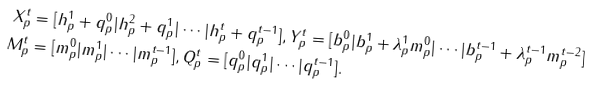<formula> <loc_0><loc_0><loc_500><loc_500>X _ { p } ^ { t } & = [ h _ { p } ^ { 1 } + q _ { p } ^ { 0 } | h _ { p } ^ { 2 } + q _ { p } ^ { 1 } | \cdots | h _ { p } ^ { t } + q _ { p } ^ { t - 1 } ] , Y _ { p } ^ { t } = [ b _ { p } ^ { 0 } | b _ { p } ^ { 1 } + \lambda _ { p } ^ { 1 } m _ { p } ^ { 0 } | \cdots | b _ { p } ^ { t - 1 } + \lambda _ { p } ^ { t - 1 } m _ { p } ^ { t - 2 } ] \\ M _ { p } ^ { t } & = [ m _ { p } ^ { 0 } | m _ { p } ^ { 1 } | \cdots | m _ { p } ^ { t - 1 } ] , Q _ { p } ^ { t } = [ q _ { p } ^ { 0 } | q _ { p } ^ { 1 } | \cdots | q _ { p } ^ { t - 1 } ] .</formula> 